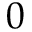Convert formula to latex. <formula><loc_0><loc_0><loc_500><loc_500>0</formula> 